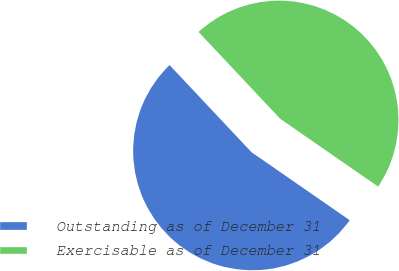Convert chart to OTSL. <chart><loc_0><loc_0><loc_500><loc_500><pie_chart><fcel>Outstanding as of December 31<fcel>Exercisable as of December 31<nl><fcel>53.35%<fcel>46.65%<nl></chart> 